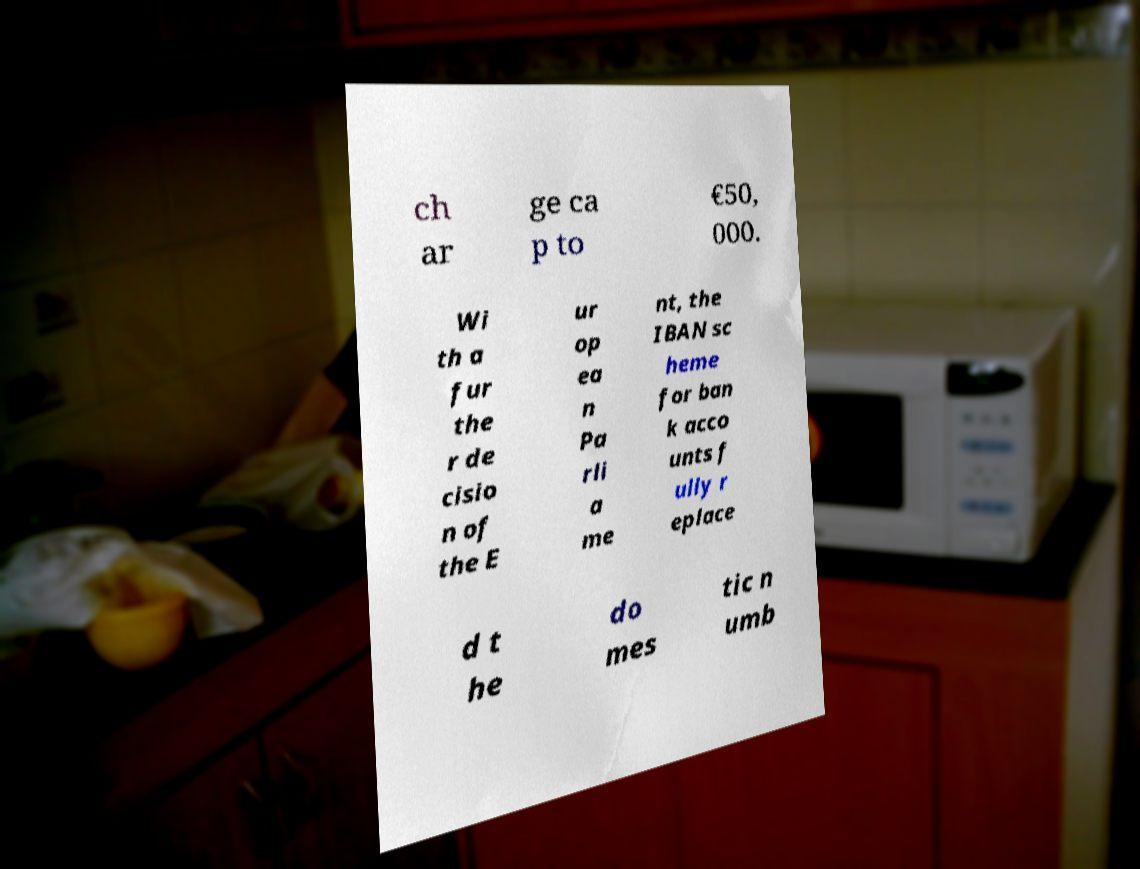I need the written content from this picture converted into text. Can you do that? ch ar ge ca p to €50, 000. Wi th a fur the r de cisio n of the E ur op ea n Pa rli a me nt, the IBAN sc heme for ban k acco unts f ully r eplace d t he do mes tic n umb 